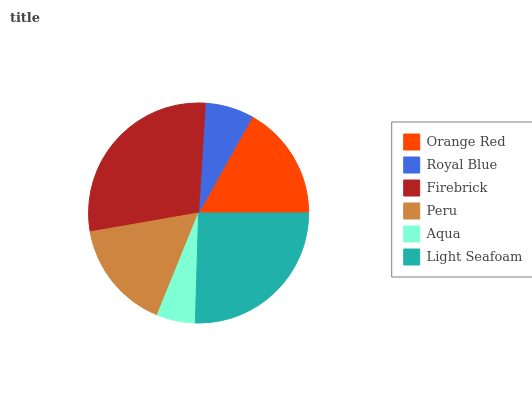Is Aqua the minimum?
Answer yes or no. Yes. Is Firebrick the maximum?
Answer yes or no. Yes. Is Royal Blue the minimum?
Answer yes or no. No. Is Royal Blue the maximum?
Answer yes or no. No. Is Orange Red greater than Royal Blue?
Answer yes or no. Yes. Is Royal Blue less than Orange Red?
Answer yes or no. Yes. Is Royal Blue greater than Orange Red?
Answer yes or no. No. Is Orange Red less than Royal Blue?
Answer yes or no. No. Is Orange Red the high median?
Answer yes or no. Yes. Is Peru the low median?
Answer yes or no. Yes. Is Royal Blue the high median?
Answer yes or no. No. Is Orange Red the low median?
Answer yes or no. No. 